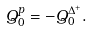Convert formula to latex. <formula><loc_0><loc_0><loc_500><loc_500>Q _ { 0 } ^ { p } = - Q _ { 0 } ^ { \Delta ^ { + } } .</formula> 